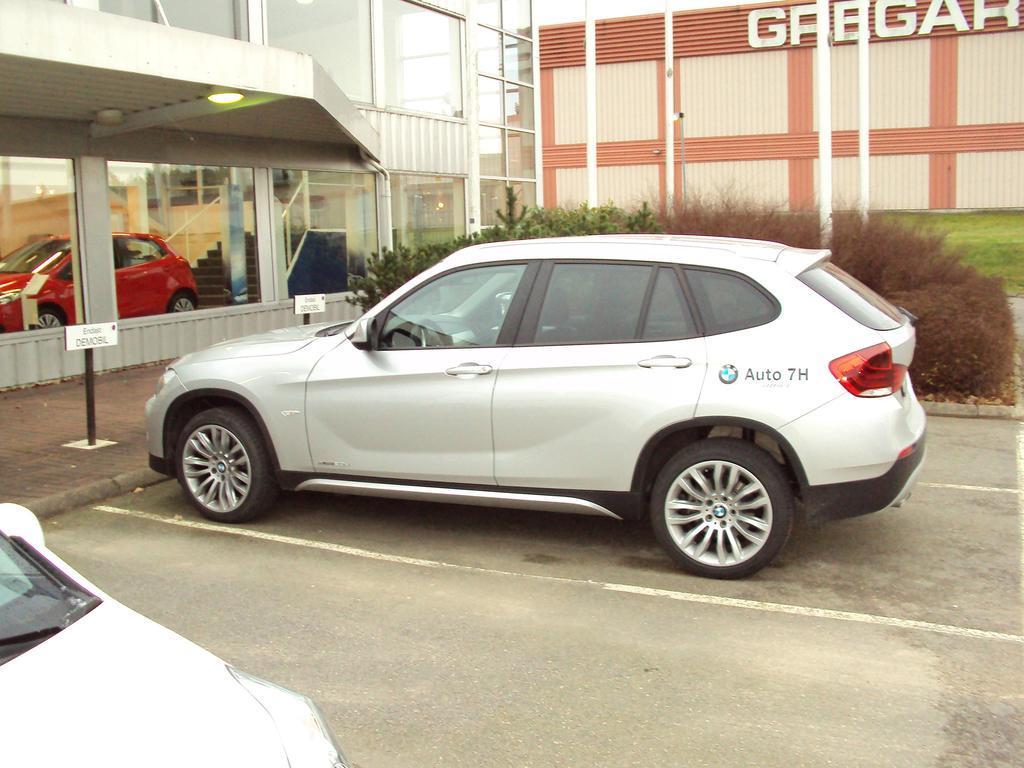How would you summarize this image in a sentence or two? This image consists of cars parked on the ground. At the bottom, there is a road. In the front, we can see the buildings. And there are plants along with green grass. 